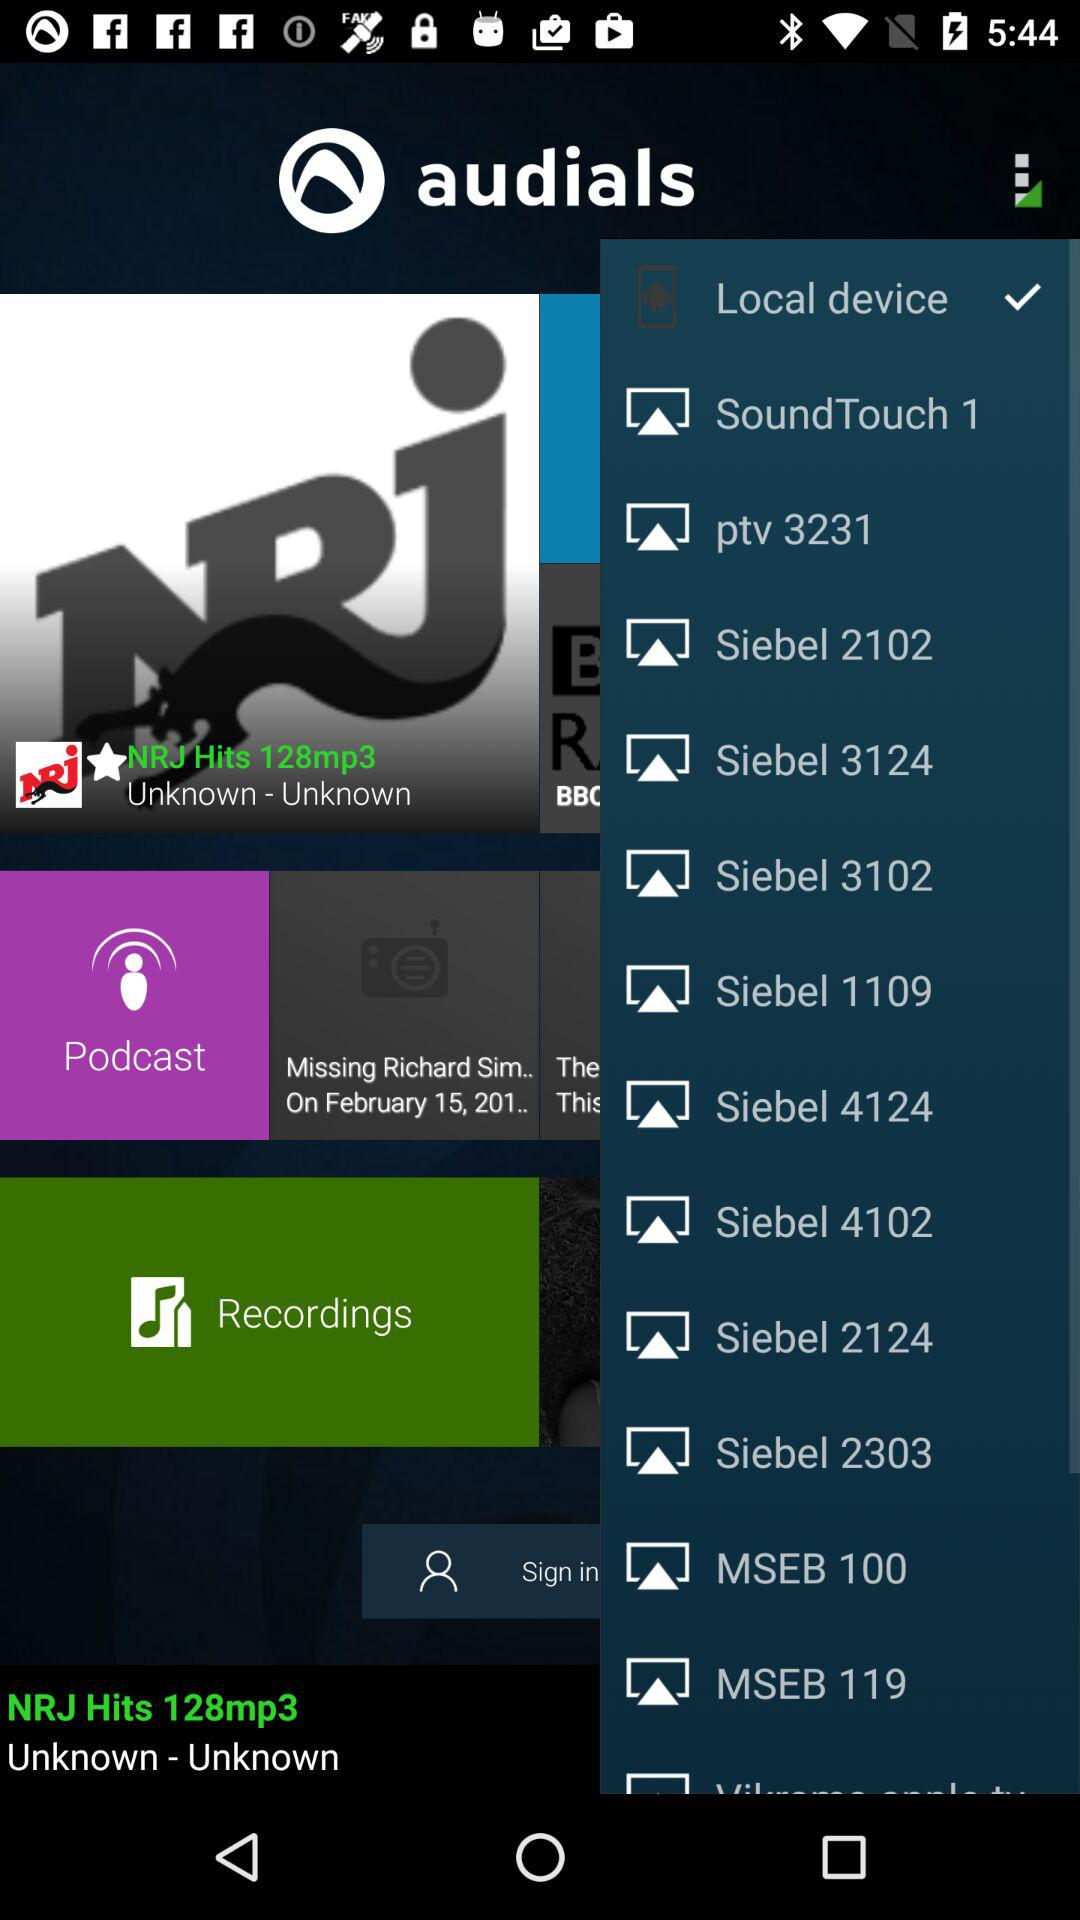How many recordings are available?
When the provided information is insufficient, respond with <no answer>. <no answer> 